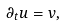Convert formula to latex. <formula><loc_0><loc_0><loc_500><loc_500>\partial _ { t } u = v ,</formula> 